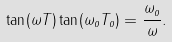<formula> <loc_0><loc_0><loc_500><loc_500>\tan ( \omega T ) \tan ( \omega _ { o } T _ { o } ) = \frac { \omega _ { o } } { \omega } .</formula> 